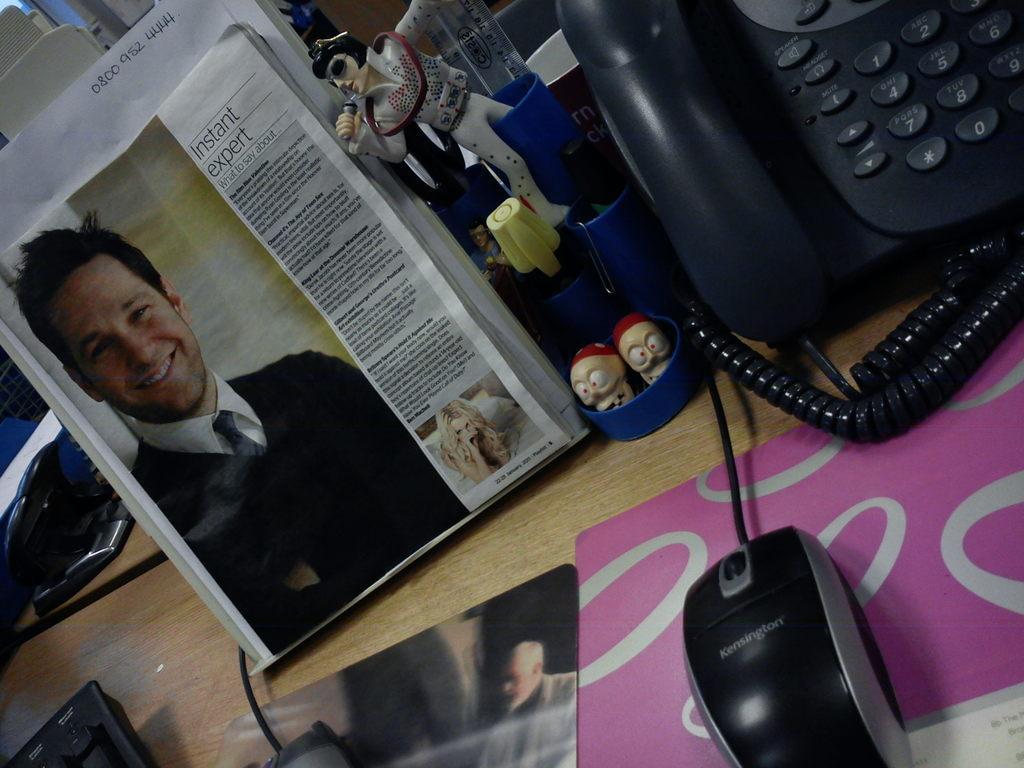Could you give a brief overview of what you see in this image? Here I can see a table on which a newspaper, book, telephone, toys, mouse, cables and some other objects are placed. On the newspaper, I can see the images of a man and a woman and also there is some text. 